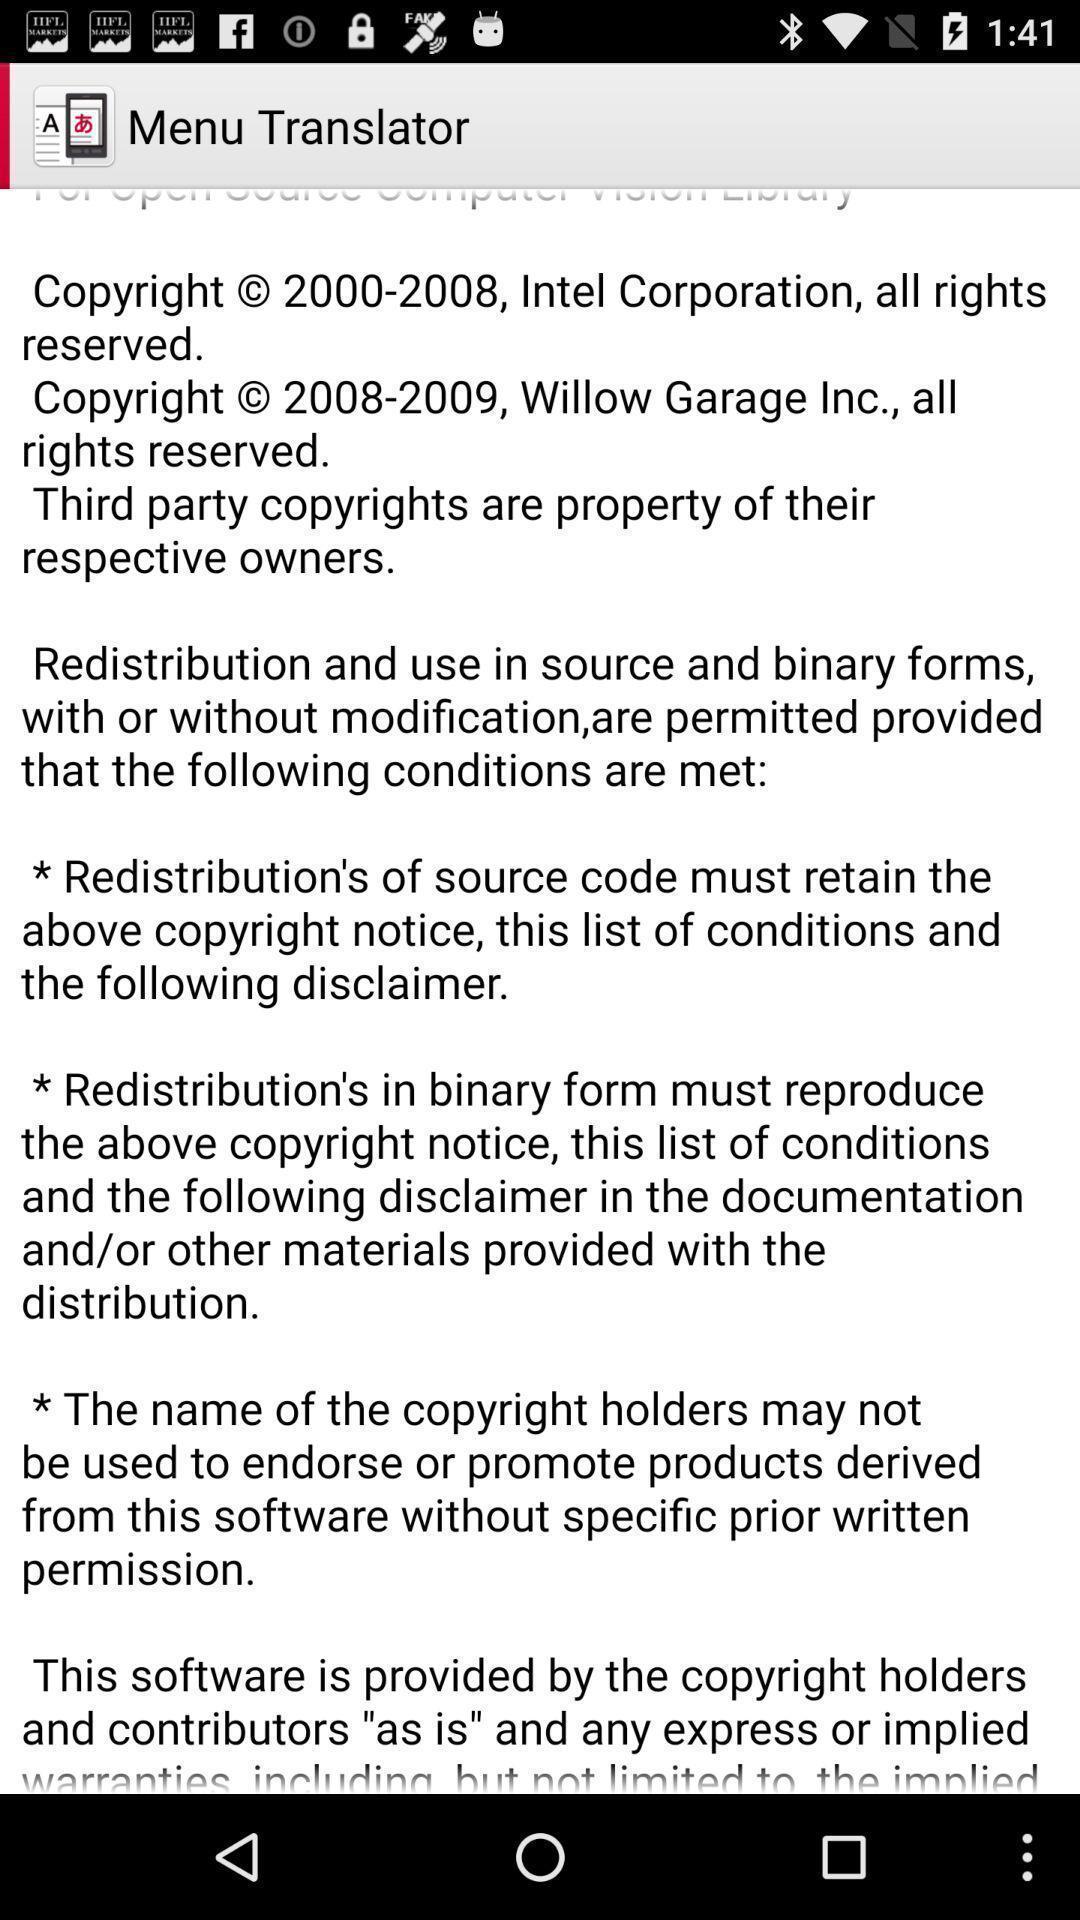Describe the content in this image. Screen displaying information about the application. 